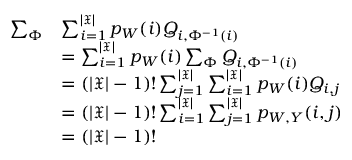<formula> <loc_0><loc_0><loc_500><loc_500>\begin{array} { r l } { \sum _ { \Phi } } & { \sum _ { i = 1 } ^ { | \mathfrak { X } | } p _ { W } ( i ) Q _ { i , \Phi ^ { - 1 } ( i ) } } \\ & { = \sum _ { i = 1 } ^ { | \mathfrak { X } | } p _ { W } ( i ) \sum _ { \Phi } Q _ { i , \Phi ^ { - 1 } ( i ) } } \\ & { = ( | \mathfrak { X } | - 1 ) ! \sum _ { j = 1 } ^ { | \mathfrak { X } | } \sum _ { i = 1 } ^ { | \mathfrak { X } | } p _ { W } ( i ) Q _ { i , j } } \\ & { = ( | \mathfrak { X } | - 1 ) ! \sum _ { i = 1 } ^ { | \mathfrak { X } | } \sum _ { j = 1 } ^ { | \mathfrak { X } | } p _ { W , Y } ( i , j ) } \\ & { = ( | \mathfrak { X } | - 1 ) ! } \end{array}</formula> 